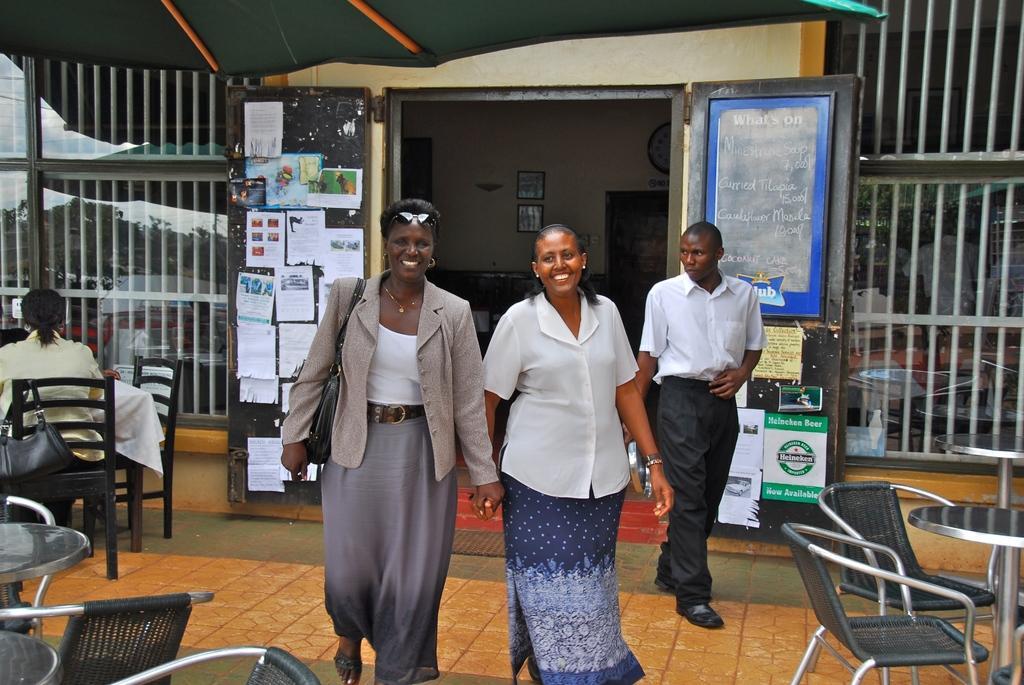Could you give a brief overview of what you see in this image? In this picture there are two women holding their hands, walking and smiling. In the background there is a man walking, also a board, there are some papers pasted to the door. In the left there is a woman sitting on the chair. 